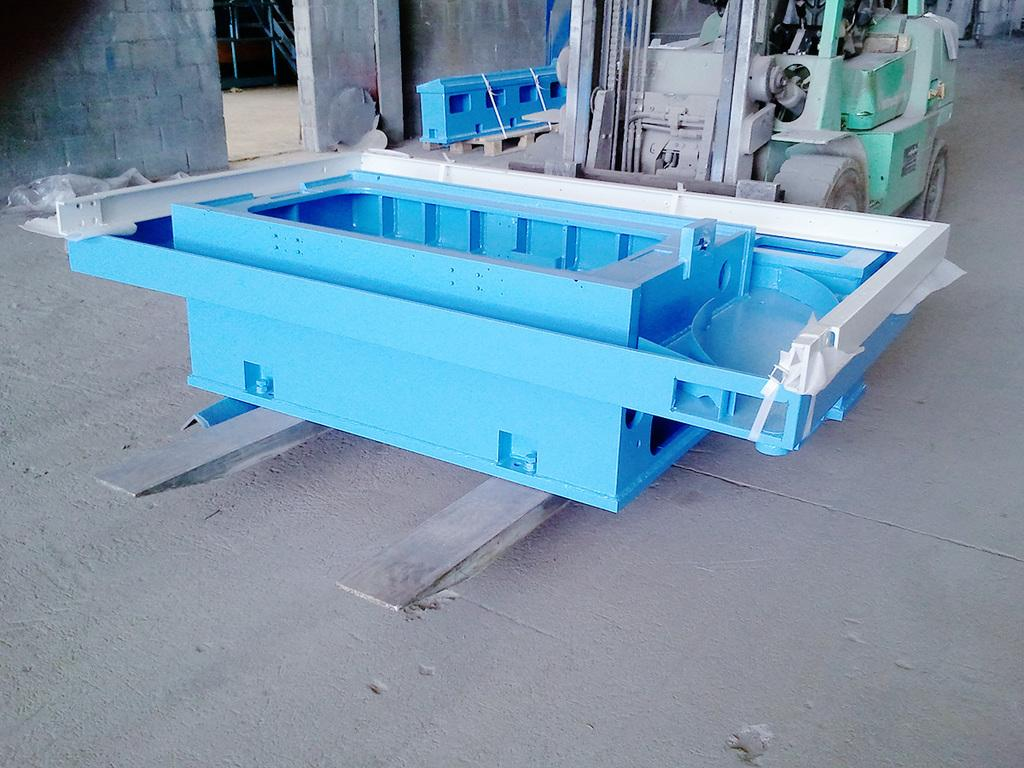What is the main object in the image? There is a metal object placed on two metal rods. What can be seen in the background of the image? There is an object placed on the ground, a machine, a wall, and a cover on the ground in the background. Can you describe the object placed on the ground in the background? The object placed on the ground in the background is not described in the facts provided. What is the purpose of the metal rods in the image? The purpose of the metal rods is not described in the facts provided. What type of soap is being used to clean the wheel in the image? There is no wheel or soap present in the image. 